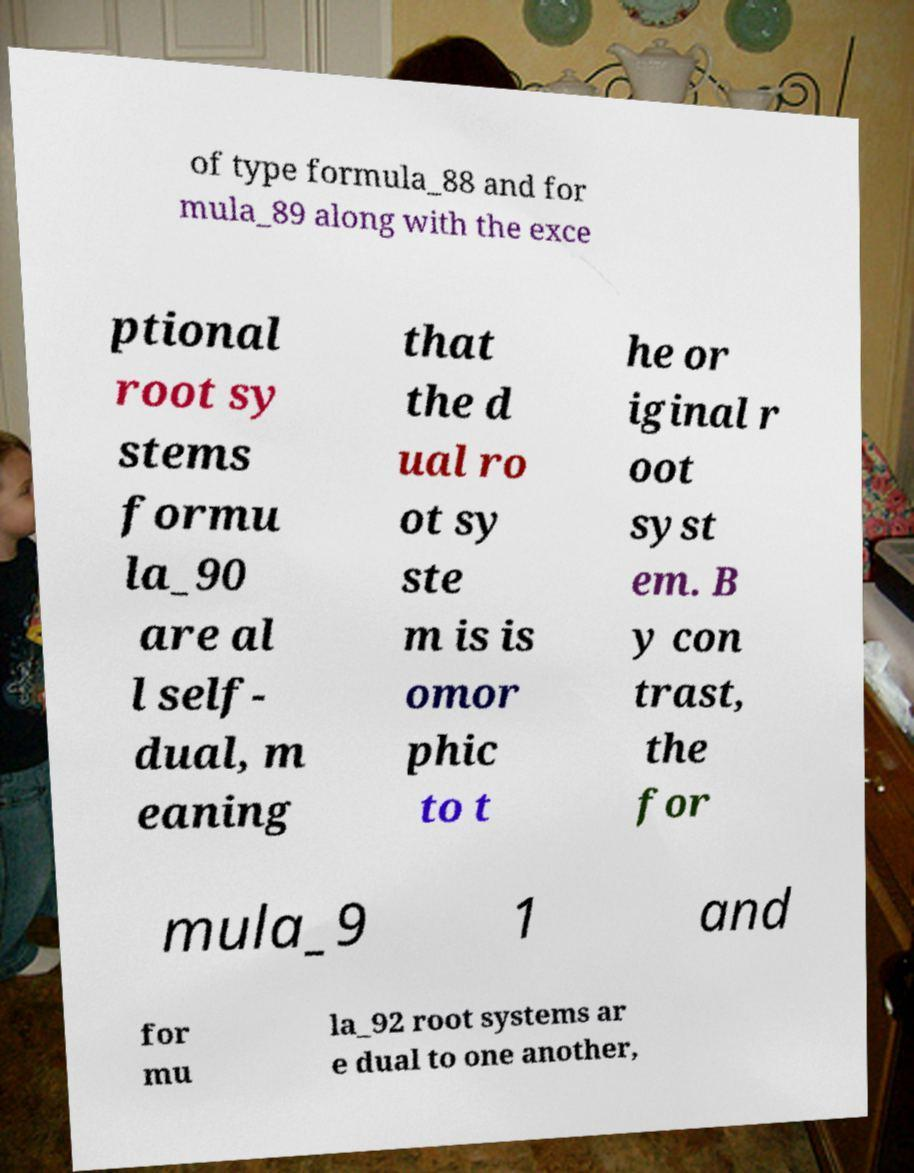There's text embedded in this image that I need extracted. Can you transcribe it verbatim? of type formula_88 and for mula_89 along with the exce ptional root sy stems formu la_90 are al l self- dual, m eaning that the d ual ro ot sy ste m is is omor phic to t he or iginal r oot syst em. B y con trast, the for mula_9 1 and for mu la_92 root systems ar e dual to one another, 